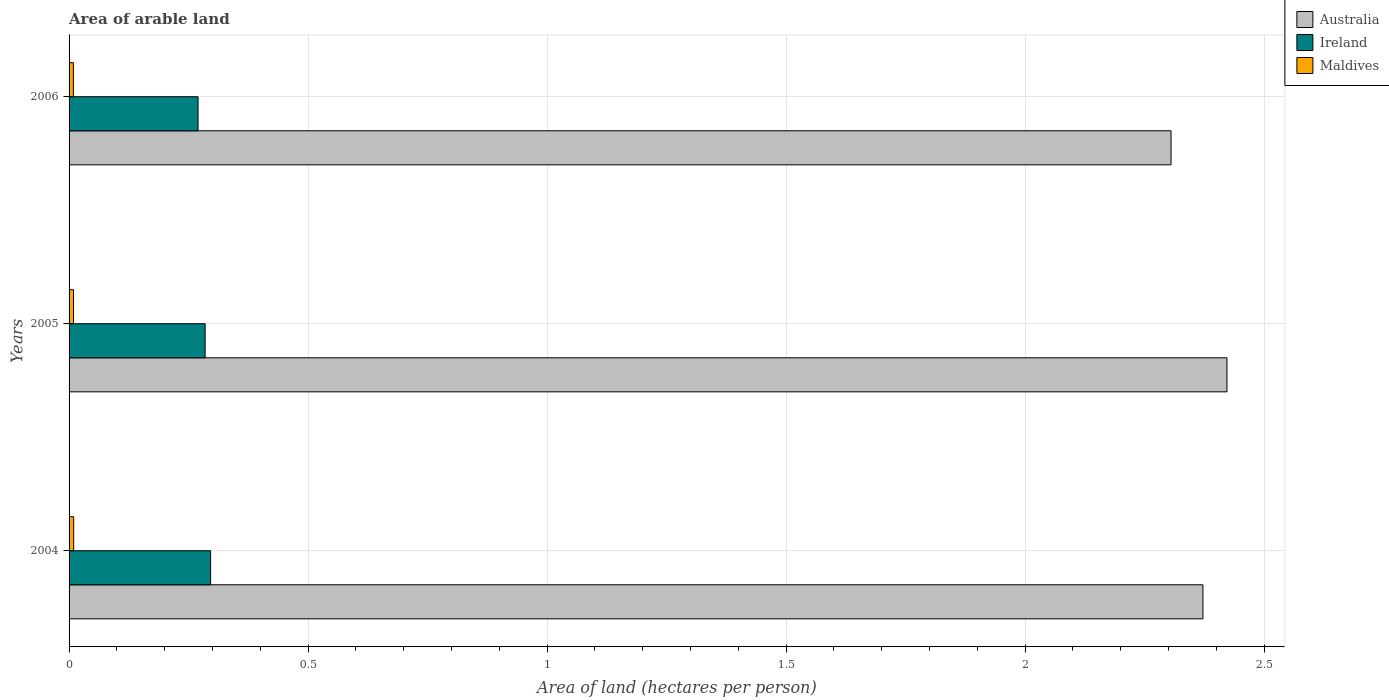How many groups of bars are there?
Your answer should be very brief. 3. Are the number of bars per tick equal to the number of legend labels?
Offer a terse response. Yes. How many bars are there on the 2nd tick from the top?
Provide a short and direct response. 3. What is the total arable land in Maldives in 2006?
Offer a terse response. 0.01. Across all years, what is the maximum total arable land in Ireland?
Ensure brevity in your answer.  0.3. Across all years, what is the minimum total arable land in Maldives?
Keep it short and to the point. 0.01. In which year was the total arable land in Maldives maximum?
Give a very brief answer. 2004. What is the total total arable land in Australia in the graph?
Your answer should be compact. 7.1. What is the difference between the total arable land in Maldives in 2005 and that in 2006?
Give a very brief answer. 0. What is the difference between the total arable land in Australia in 2004 and the total arable land in Maldives in 2006?
Your answer should be very brief. 2.36. What is the average total arable land in Maldives per year?
Your response must be concise. 0.01. In the year 2004, what is the difference between the total arable land in Maldives and total arable land in Ireland?
Your response must be concise. -0.29. In how many years, is the total arable land in Ireland greater than 1.2 hectares per person?
Your response must be concise. 0. What is the ratio of the total arable land in Australia in 2004 to that in 2006?
Your response must be concise. 1.03. Is the difference between the total arable land in Maldives in 2004 and 2005 greater than the difference between the total arable land in Ireland in 2004 and 2005?
Provide a short and direct response. No. What is the difference between the highest and the second highest total arable land in Australia?
Give a very brief answer. 0.05. What is the difference between the highest and the lowest total arable land in Australia?
Offer a very short reply. 0.12. Is the sum of the total arable land in Australia in 2004 and 2006 greater than the maximum total arable land in Maldives across all years?
Offer a terse response. Yes. What does the 1st bar from the top in 2005 represents?
Offer a terse response. Maldives. What does the 2nd bar from the bottom in 2004 represents?
Provide a short and direct response. Ireland. Is it the case that in every year, the sum of the total arable land in Ireland and total arable land in Maldives is greater than the total arable land in Australia?
Make the answer very short. No. What is the difference between two consecutive major ticks on the X-axis?
Provide a short and direct response. 0.5. Are the values on the major ticks of X-axis written in scientific E-notation?
Provide a succinct answer. No. Does the graph contain any zero values?
Provide a short and direct response. No. How many legend labels are there?
Your answer should be compact. 3. What is the title of the graph?
Keep it short and to the point. Area of arable land. Does "Sint Maarten (Dutch part)" appear as one of the legend labels in the graph?
Make the answer very short. No. What is the label or title of the X-axis?
Ensure brevity in your answer.  Area of land (hectares per person). What is the Area of land (hectares per person) in Australia in 2004?
Offer a very short reply. 2.37. What is the Area of land (hectares per person) of Ireland in 2004?
Your answer should be compact. 0.3. What is the Area of land (hectares per person) in Maldives in 2004?
Your answer should be very brief. 0.01. What is the Area of land (hectares per person) in Australia in 2005?
Provide a succinct answer. 2.42. What is the Area of land (hectares per person) of Ireland in 2005?
Provide a succinct answer. 0.28. What is the Area of land (hectares per person) in Maldives in 2005?
Your response must be concise. 0.01. What is the Area of land (hectares per person) in Australia in 2006?
Give a very brief answer. 2.31. What is the Area of land (hectares per person) in Ireland in 2006?
Provide a short and direct response. 0.27. What is the Area of land (hectares per person) of Maldives in 2006?
Offer a very short reply. 0.01. Across all years, what is the maximum Area of land (hectares per person) in Australia?
Provide a short and direct response. 2.42. Across all years, what is the maximum Area of land (hectares per person) of Ireland?
Ensure brevity in your answer.  0.3. Across all years, what is the maximum Area of land (hectares per person) in Maldives?
Your answer should be compact. 0.01. Across all years, what is the minimum Area of land (hectares per person) in Australia?
Give a very brief answer. 2.31. Across all years, what is the minimum Area of land (hectares per person) of Ireland?
Your answer should be very brief. 0.27. Across all years, what is the minimum Area of land (hectares per person) of Maldives?
Ensure brevity in your answer.  0.01. What is the total Area of land (hectares per person) of Australia in the graph?
Provide a short and direct response. 7.1. What is the total Area of land (hectares per person) in Ireland in the graph?
Offer a very short reply. 0.85. What is the total Area of land (hectares per person) of Maldives in the graph?
Your answer should be compact. 0.03. What is the difference between the Area of land (hectares per person) of Australia in 2004 and that in 2005?
Your answer should be very brief. -0.05. What is the difference between the Area of land (hectares per person) of Ireland in 2004 and that in 2005?
Keep it short and to the point. 0.01. What is the difference between the Area of land (hectares per person) in Australia in 2004 and that in 2006?
Give a very brief answer. 0.07. What is the difference between the Area of land (hectares per person) in Ireland in 2004 and that in 2006?
Offer a terse response. 0.03. What is the difference between the Area of land (hectares per person) in Maldives in 2004 and that in 2006?
Offer a very short reply. 0. What is the difference between the Area of land (hectares per person) in Australia in 2005 and that in 2006?
Your answer should be compact. 0.12. What is the difference between the Area of land (hectares per person) in Ireland in 2005 and that in 2006?
Provide a succinct answer. 0.01. What is the difference between the Area of land (hectares per person) in Australia in 2004 and the Area of land (hectares per person) in Ireland in 2005?
Offer a very short reply. 2.09. What is the difference between the Area of land (hectares per person) of Australia in 2004 and the Area of land (hectares per person) of Maldives in 2005?
Keep it short and to the point. 2.36. What is the difference between the Area of land (hectares per person) in Ireland in 2004 and the Area of land (hectares per person) in Maldives in 2005?
Make the answer very short. 0.29. What is the difference between the Area of land (hectares per person) in Australia in 2004 and the Area of land (hectares per person) in Ireland in 2006?
Provide a short and direct response. 2.1. What is the difference between the Area of land (hectares per person) in Australia in 2004 and the Area of land (hectares per person) in Maldives in 2006?
Keep it short and to the point. 2.36. What is the difference between the Area of land (hectares per person) in Ireland in 2004 and the Area of land (hectares per person) in Maldives in 2006?
Your response must be concise. 0.29. What is the difference between the Area of land (hectares per person) of Australia in 2005 and the Area of land (hectares per person) of Ireland in 2006?
Your response must be concise. 2.15. What is the difference between the Area of land (hectares per person) of Australia in 2005 and the Area of land (hectares per person) of Maldives in 2006?
Keep it short and to the point. 2.41. What is the difference between the Area of land (hectares per person) in Ireland in 2005 and the Area of land (hectares per person) in Maldives in 2006?
Keep it short and to the point. 0.28. What is the average Area of land (hectares per person) of Australia per year?
Ensure brevity in your answer.  2.37. What is the average Area of land (hectares per person) in Ireland per year?
Your answer should be very brief. 0.28. What is the average Area of land (hectares per person) of Maldives per year?
Provide a succinct answer. 0.01. In the year 2004, what is the difference between the Area of land (hectares per person) of Australia and Area of land (hectares per person) of Ireland?
Provide a short and direct response. 2.08. In the year 2004, what is the difference between the Area of land (hectares per person) in Australia and Area of land (hectares per person) in Maldives?
Provide a succinct answer. 2.36. In the year 2004, what is the difference between the Area of land (hectares per person) of Ireland and Area of land (hectares per person) of Maldives?
Give a very brief answer. 0.29. In the year 2005, what is the difference between the Area of land (hectares per person) of Australia and Area of land (hectares per person) of Ireland?
Offer a very short reply. 2.14. In the year 2005, what is the difference between the Area of land (hectares per person) in Australia and Area of land (hectares per person) in Maldives?
Your answer should be compact. 2.41. In the year 2005, what is the difference between the Area of land (hectares per person) of Ireland and Area of land (hectares per person) of Maldives?
Make the answer very short. 0.28. In the year 2006, what is the difference between the Area of land (hectares per person) of Australia and Area of land (hectares per person) of Ireland?
Ensure brevity in your answer.  2.04. In the year 2006, what is the difference between the Area of land (hectares per person) in Australia and Area of land (hectares per person) in Maldives?
Offer a very short reply. 2.3. In the year 2006, what is the difference between the Area of land (hectares per person) in Ireland and Area of land (hectares per person) in Maldives?
Provide a succinct answer. 0.26. What is the ratio of the Area of land (hectares per person) in Australia in 2004 to that in 2005?
Offer a very short reply. 0.98. What is the ratio of the Area of land (hectares per person) of Ireland in 2004 to that in 2005?
Your answer should be compact. 1.04. What is the ratio of the Area of land (hectares per person) in Maldives in 2004 to that in 2005?
Make the answer very short. 1.03. What is the ratio of the Area of land (hectares per person) in Australia in 2004 to that in 2006?
Your answer should be very brief. 1.03. What is the ratio of the Area of land (hectares per person) of Ireland in 2004 to that in 2006?
Ensure brevity in your answer.  1.1. What is the ratio of the Area of land (hectares per person) of Maldives in 2004 to that in 2006?
Keep it short and to the point. 1.07. What is the ratio of the Area of land (hectares per person) in Australia in 2005 to that in 2006?
Keep it short and to the point. 1.05. What is the ratio of the Area of land (hectares per person) of Ireland in 2005 to that in 2006?
Provide a succinct answer. 1.05. What is the ratio of the Area of land (hectares per person) of Maldives in 2005 to that in 2006?
Your response must be concise. 1.04. What is the difference between the highest and the second highest Area of land (hectares per person) of Australia?
Provide a short and direct response. 0.05. What is the difference between the highest and the second highest Area of land (hectares per person) in Ireland?
Give a very brief answer. 0.01. What is the difference between the highest and the second highest Area of land (hectares per person) of Maldives?
Ensure brevity in your answer.  0. What is the difference between the highest and the lowest Area of land (hectares per person) of Australia?
Make the answer very short. 0.12. What is the difference between the highest and the lowest Area of land (hectares per person) in Ireland?
Offer a very short reply. 0.03. What is the difference between the highest and the lowest Area of land (hectares per person) of Maldives?
Give a very brief answer. 0. 